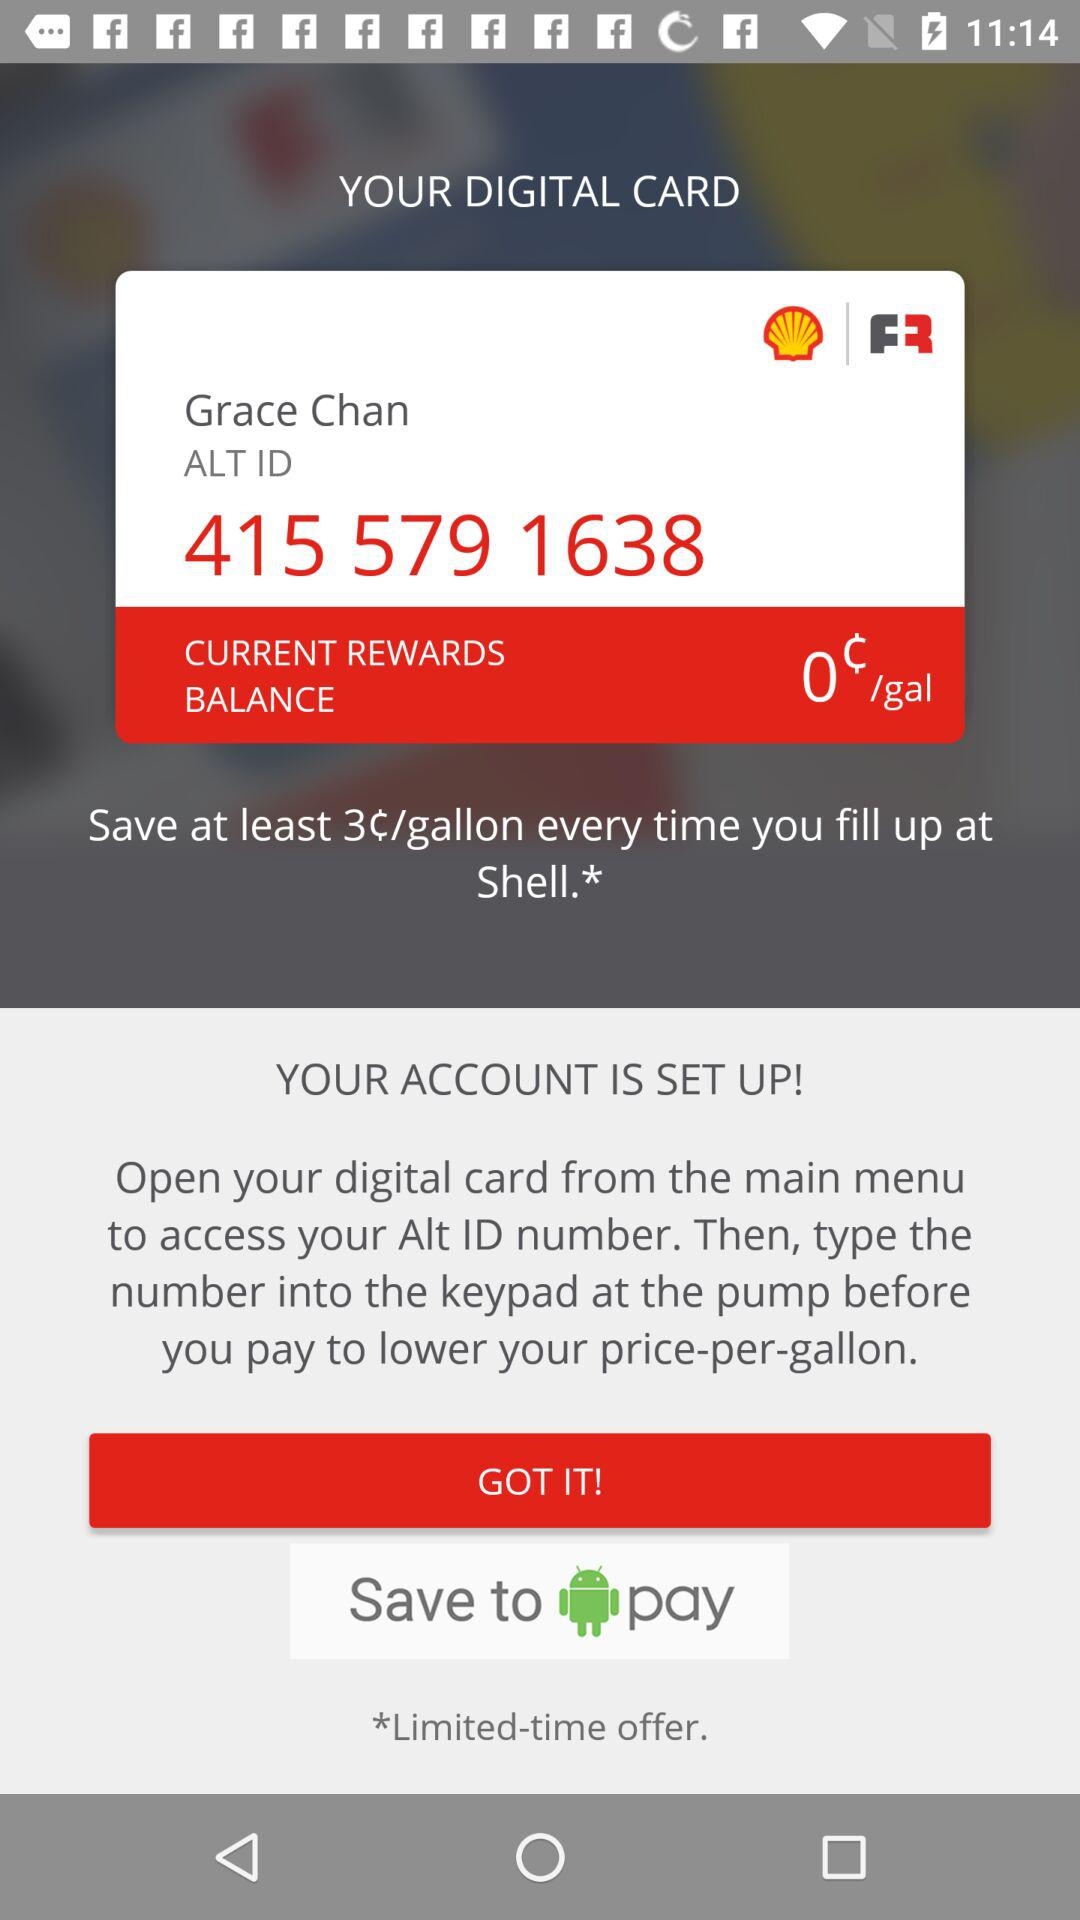How much can we save every time? You can save at least 3 cents per gallon every time. 